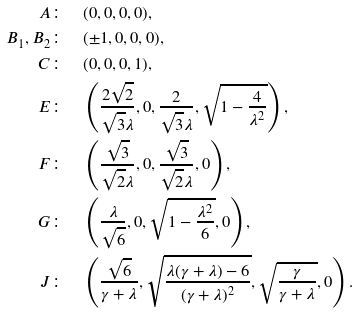Convert formula to latex. <formula><loc_0><loc_0><loc_500><loc_500>A & \colon \quad ( 0 , 0 , 0 , 0 ) , \\ B _ { 1 } , B _ { 2 } & \colon \quad ( \pm 1 , 0 , 0 , 0 ) , \\ C & \colon \quad ( 0 , 0 , 0 , 1 ) , \\ E & \colon \quad \left ( \frac { 2 \sqrt { 2 } } { \sqrt { 3 } \lambda } , 0 , \frac { 2 } { \sqrt { 3 } \lambda } , \sqrt { 1 - \frac { 4 } { \lambda ^ { 2 } } } \right ) , \\ F & \colon \quad \left ( \frac { \sqrt { 3 } } { \sqrt { 2 } \lambda } , 0 , \frac { \sqrt { 3 } } { \sqrt { 2 } \lambda } , 0 \right ) , \\ G & \colon \quad \left ( \frac { \lambda } { \sqrt { 6 } } , 0 , \sqrt { 1 - \frac { \lambda ^ { 2 } } { 6 } } , 0 \right ) , \\ J & \colon \quad \left ( \frac { \sqrt { 6 } } { \gamma + \lambda } , \sqrt { \frac { \lambda ( \gamma + \lambda ) - 6 } { ( \gamma + \lambda ) ^ { 2 } } } , \sqrt { \frac { \gamma } { \gamma + \lambda } } , 0 \right ) .</formula> 